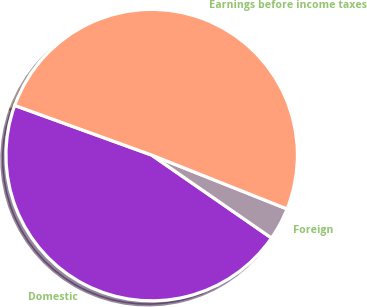Convert chart. <chart><loc_0><loc_0><loc_500><loc_500><pie_chart><fcel>Domestic<fcel>Foreign<fcel>Earnings before income taxes<nl><fcel>45.9%<fcel>3.61%<fcel>50.49%<nl></chart> 